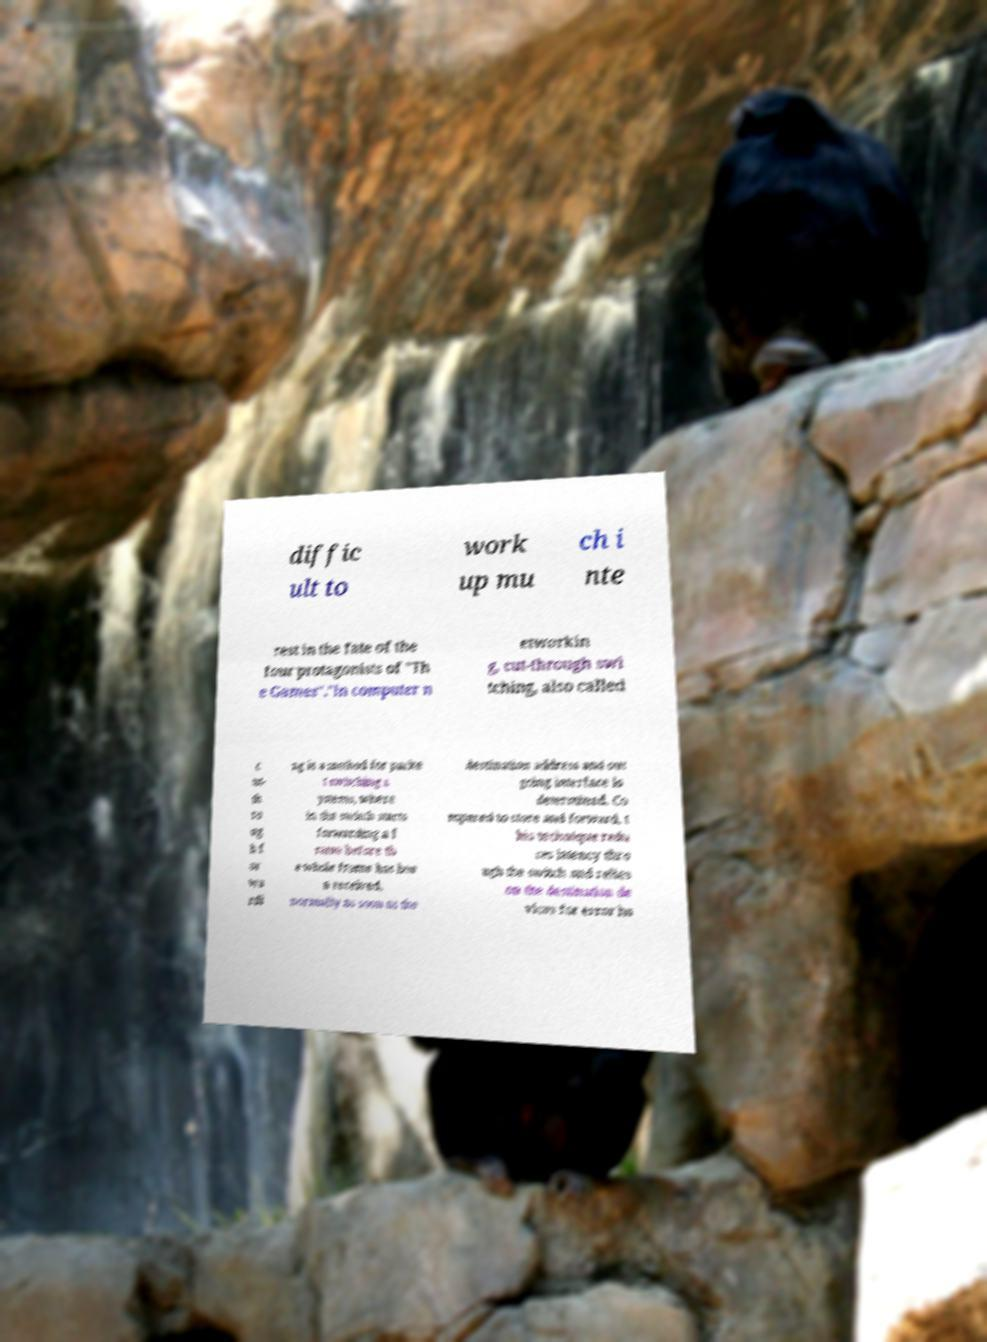Could you extract and type out the text from this image? diffic ult to work up mu ch i nte rest in the fate of the four protagonists of "Th e Games"."In computer n etworkin g, cut-through swi tching, also called c ut- th ro ug h f or wa rdi ng is a method for packe t switching s ystems, where in the switch starts forwarding a f rame before th e whole frame has bee n received, normally as soon as the destination address and out going interface is determined. Co mpared to store and forward, t his technique redu ces latency thro ugh the switch and relies on the destination de vices for error ha 